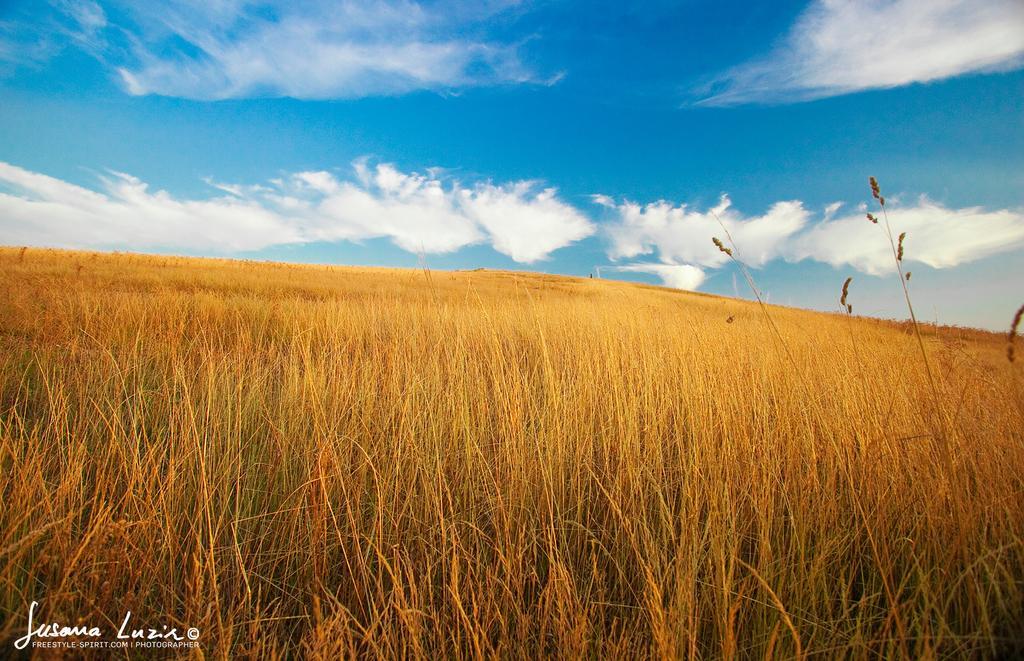Could you give a brief overview of what you see in this image? On the bottom left, there is a watermark. In the background, there is dry grass on the ground and there are clouds in the blue sky. 